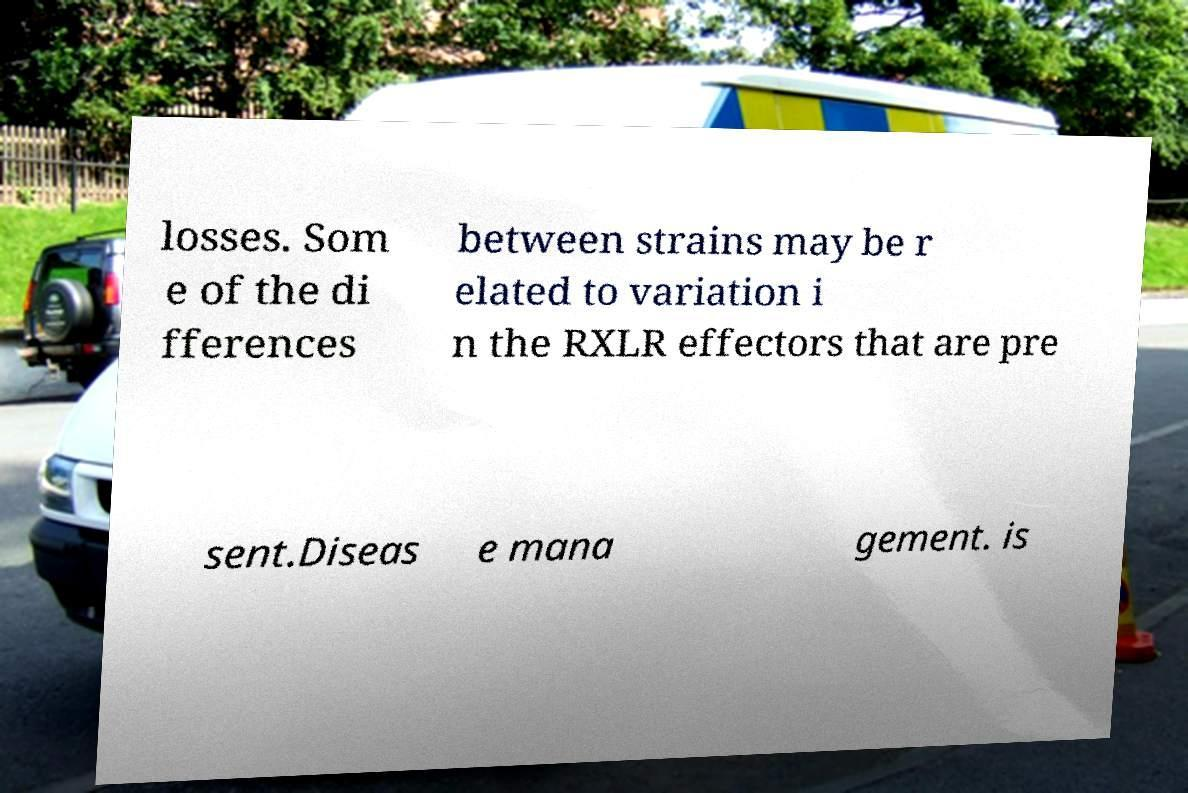Please identify and transcribe the text found in this image. losses. Som e of the di fferences between strains may be r elated to variation i n the RXLR effectors that are pre sent.Diseas e mana gement. is 